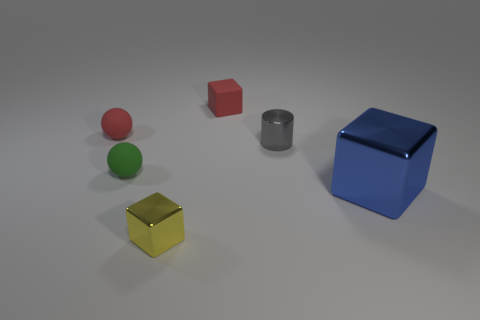Add 3 tiny red blocks. How many objects exist? 9 Subtract all spheres. How many objects are left? 4 Add 4 large shiny cubes. How many large shiny cubes are left? 5 Add 4 gray objects. How many gray objects exist? 5 Subtract 0 blue balls. How many objects are left? 6 Subtract all small shiny cylinders. Subtract all brown shiny cylinders. How many objects are left? 5 